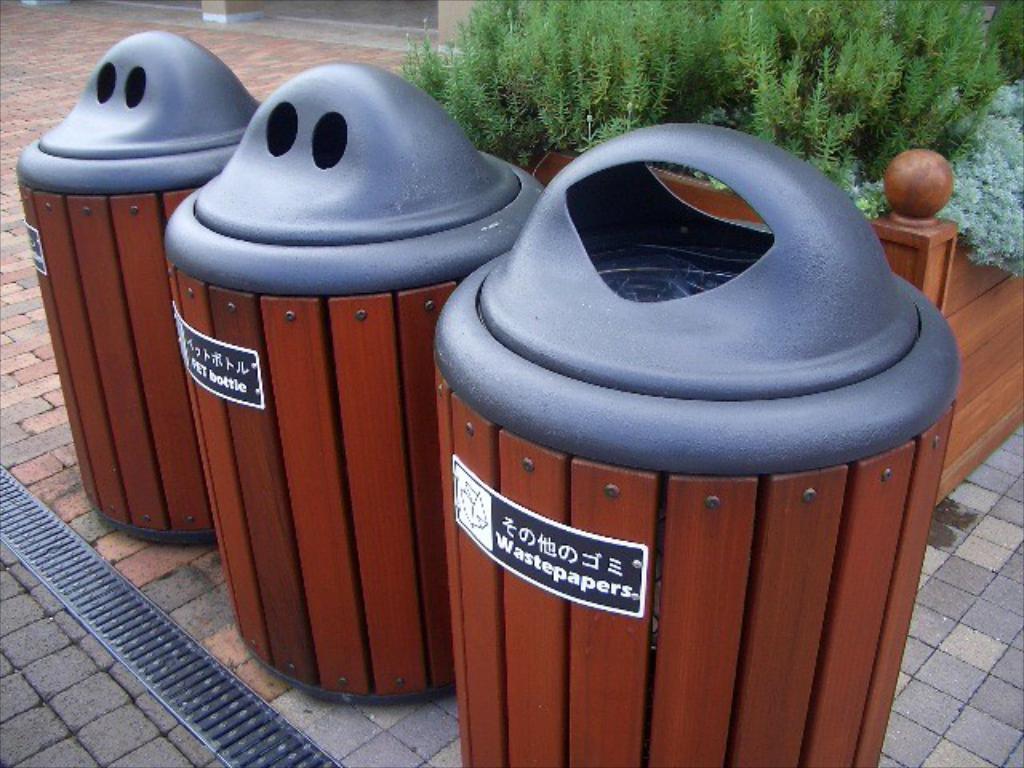What does a container hold?
Provide a succinct answer. Wastepapers. What should be placed in the middle bin?
Your answer should be compact. Bottle. 